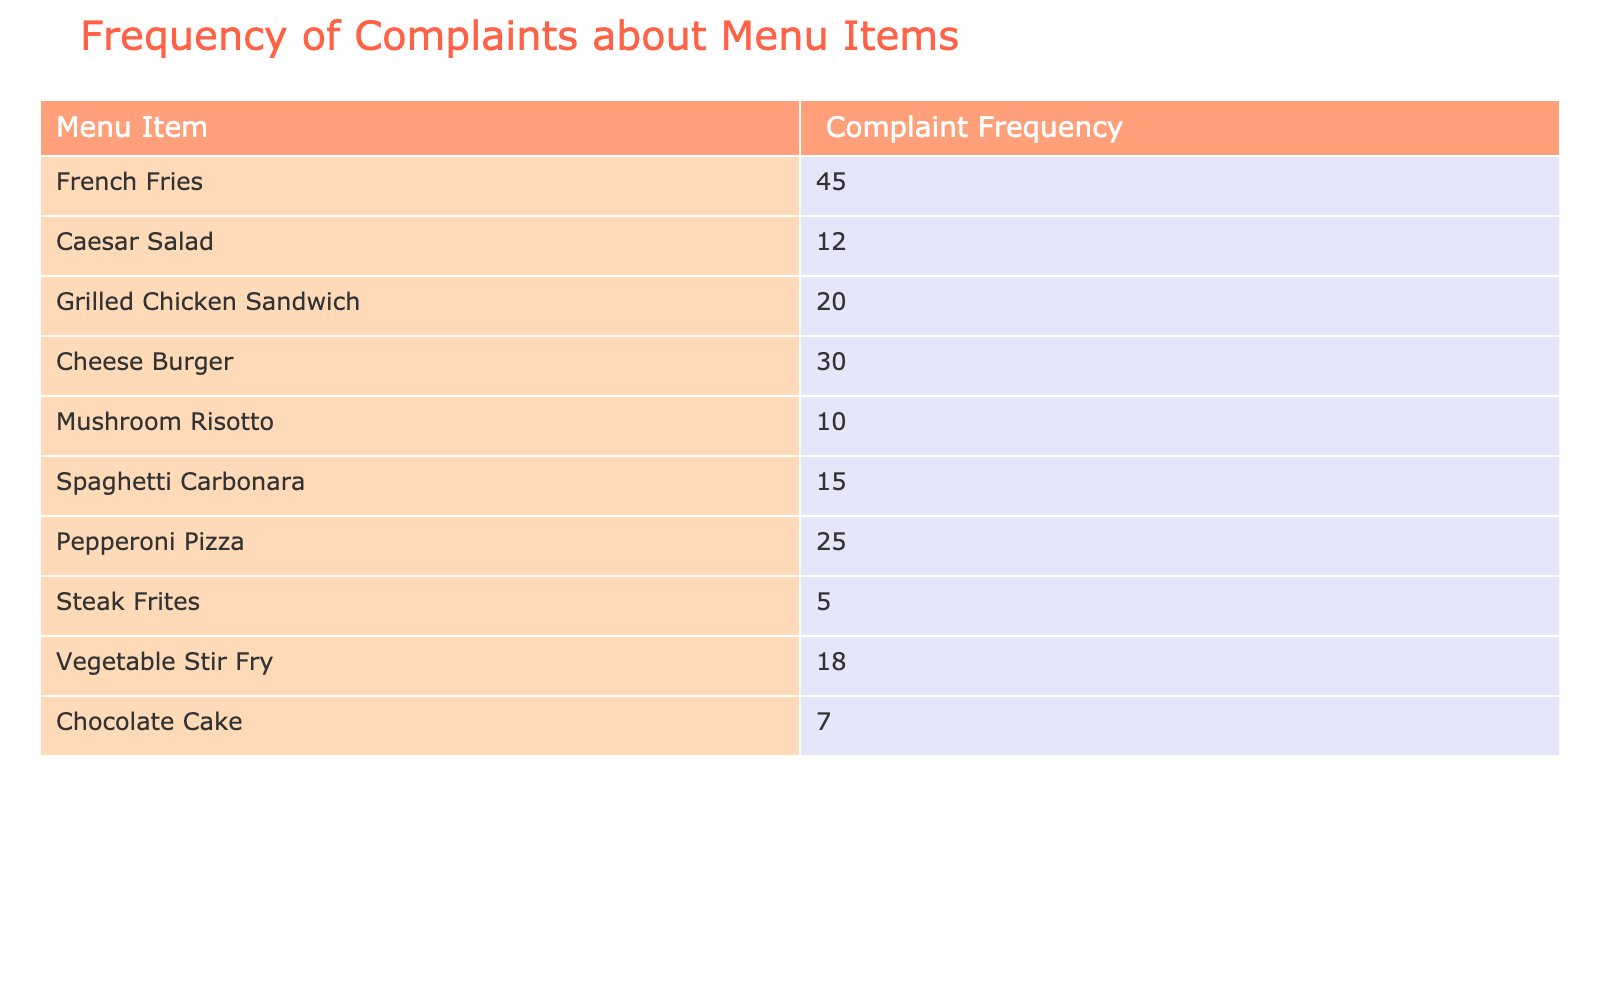What menu item has the highest complaint frequency? The table lists the complaint frequencies for each menu item. By scanning the values, 'French Fries' has the highest complaint frequency at 45.
Answer: French Fries What is the total number of complaints about the Caesar Salad and Mushroom Risotto combined? To find the total, we add the complaints for Caesar Salad (12) and Mushroom Risotto (10). So, 12 + 10 = 22.
Answer: 22 How many more complaints does the Cheese Burger have compared to the Steak Frites? First, we note the complaints: Cheese Burger has 30, and Steak Frites has 5. The difference is calculated as 30 - 5 = 25.
Answer: 25 Do more complaints occur for Pepperoni Pizza than for Grilled Chicken Sandwich? Pepperoni Pizza has 25 complaints while Grilled Chicken Sandwich has 20. Since 25 is greater than 20, the statement is true.
Answer: Yes What is the average complaint frequency across all the menu items? To find the average, sum all the complaint frequencies: 45 + 12 + 20 + 30 + 10 + 15 + 25 + 5 + 18 + 7 =  187. There are 10 items, so the average is 187/10 = 18.7.
Answer: 18.7 Which menu item has the lowest number of complaints? Looking through the table, 'Steak Frites' has the lowest complaint frequency at 5.
Answer: Steak Frites How many items have complaint frequencies greater than 20? The items with frequencies above 20 are French Fries (45), Cheese Burger (30), and Pepperoni Pizza (25). That's a total of 3 items.
Answer: 3 Is the complaint frequency for the Vegetable Stir Fry greater than the average of 18.7? The complaint frequency for Vegetable Stir Fry is 18, which is less than 18.7. Therefore, the statement is false.
Answer: No What is the combined complaint frequency of the items with less than 15 complaints? The items with less than 15 complaints are Mushroom Risotto (10), Chocolate Cake (7), and Steak Frites (5). Adding these gives 10 + 7 + 5 = 22.
Answer: 22 